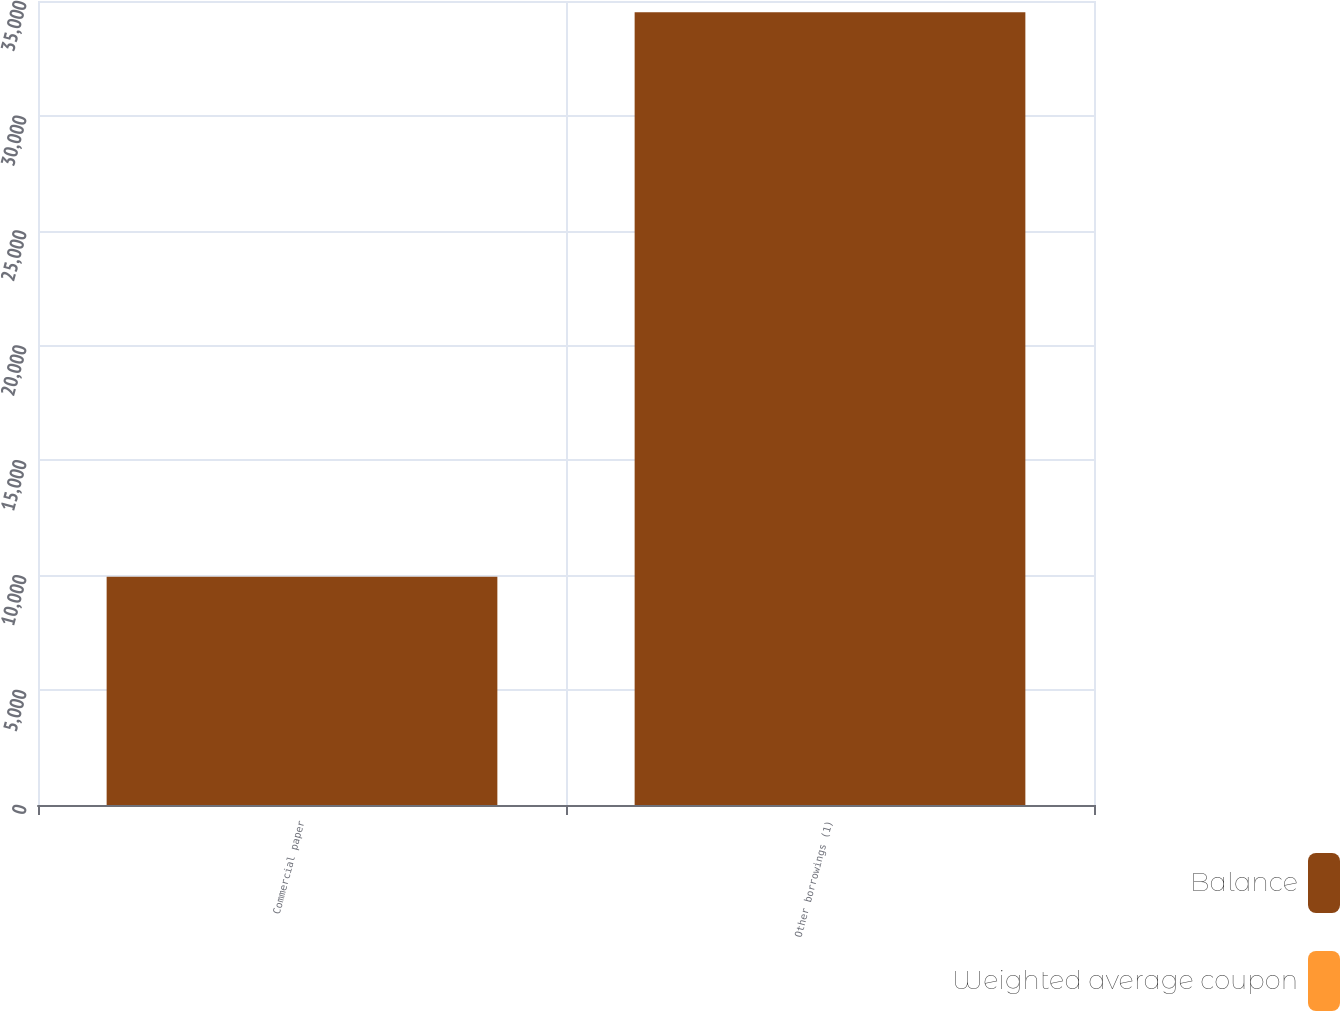Convert chart. <chart><loc_0><loc_0><loc_500><loc_500><stacked_bar_chart><ecel><fcel>Commercial paper<fcel>Other borrowings (1)<nl><fcel>Balance<fcel>9940<fcel>34512<nl><fcel>Weighted average coupon<fcel>1.28<fcel>1.62<nl></chart> 